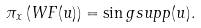Convert formula to latex. <formula><loc_0><loc_0><loc_500><loc_500>\pi _ { x } \left ( W F ( u ) \right ) = \sin g s u p p ( u ) .</formula> 